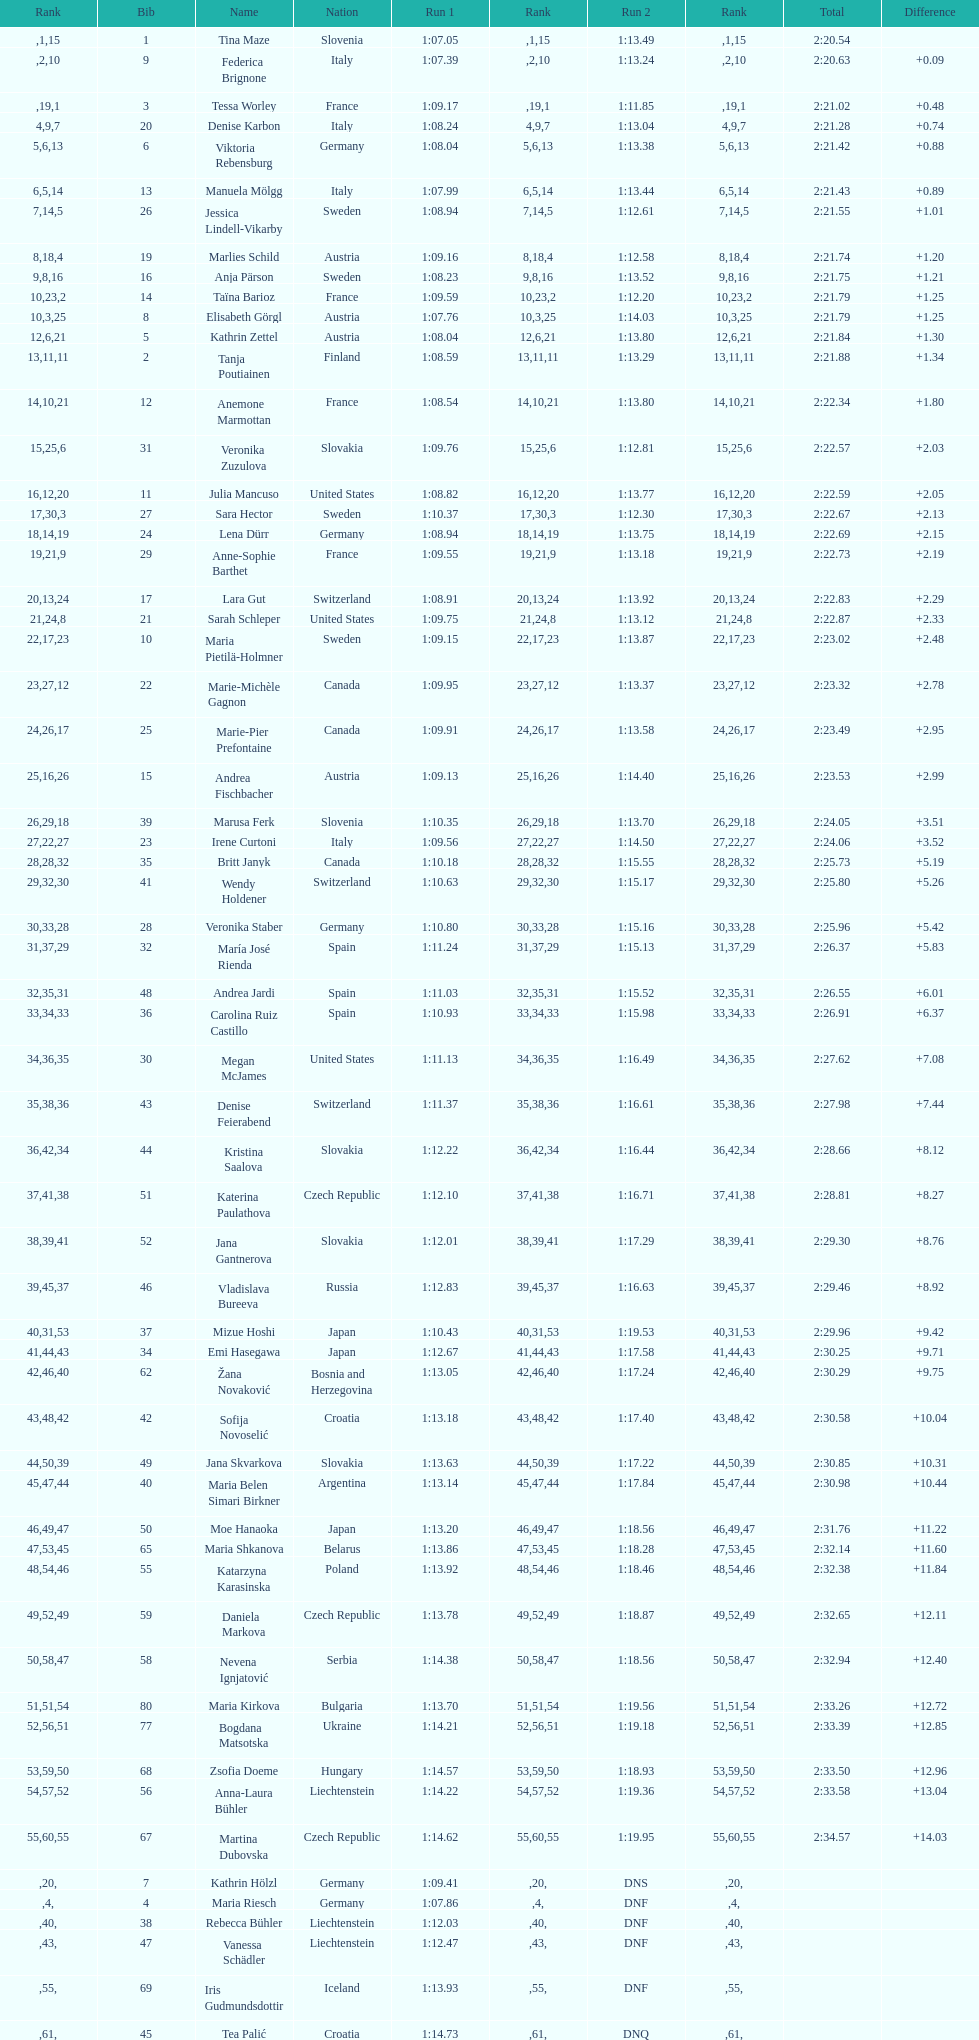How much time did tina maze require to complete the race? 2:20.54. 